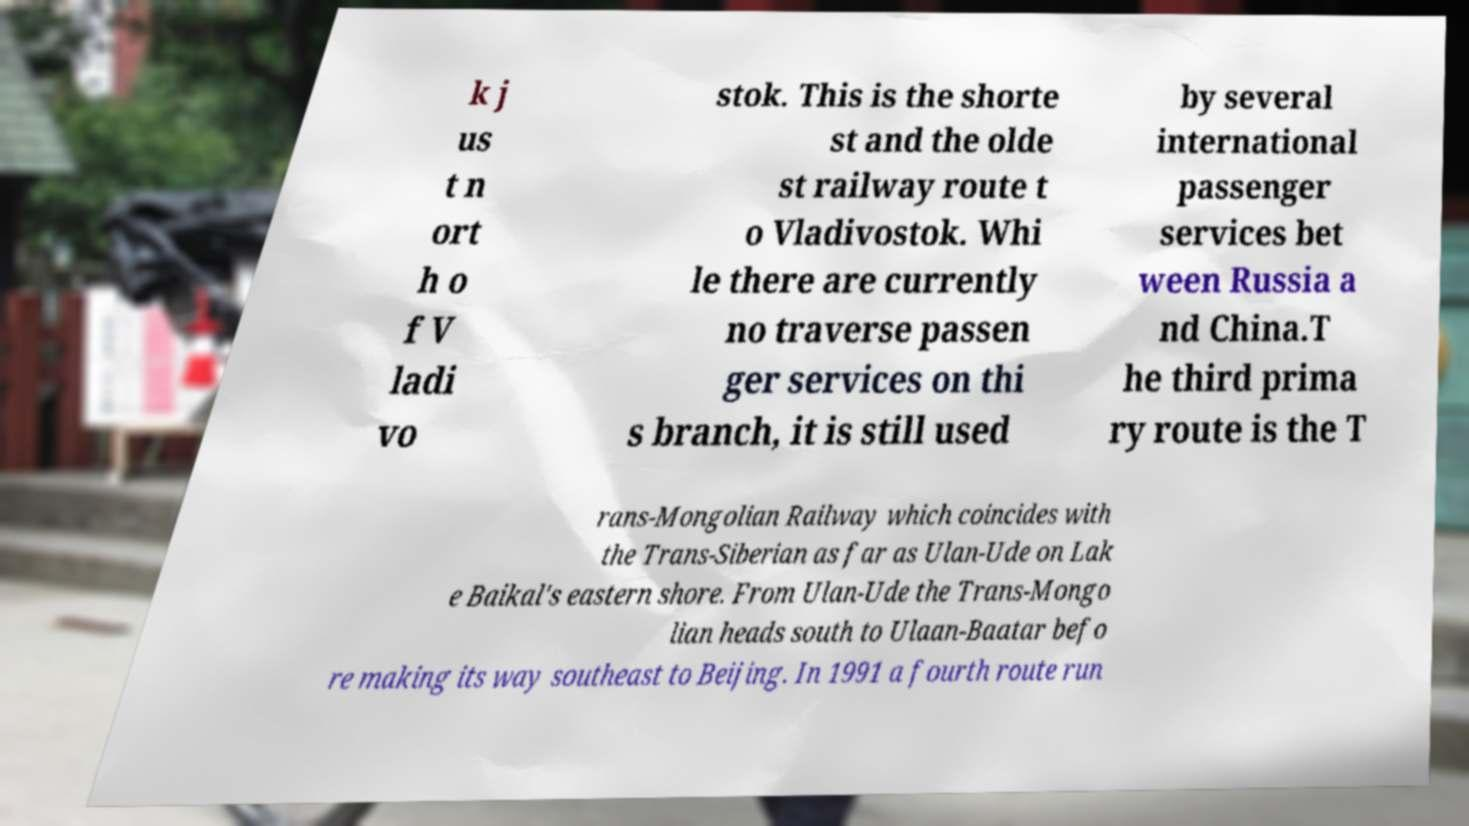Can you read and provide the text displayed in the image?This photo seems to have some interesting text. Can you extract and type it out for me? k j us t n ort h o f V ladi vo stok. This is the shorte st and the olde st railway route t o Vladivostok. Whi le there are currently no traverse passen ger services on thi s branch, it is still used by several international passenger services bet ween Russia a nd China.T he third prima ry route is the T rans-Mongolian Railway which coincides with the Trans-Siberian as far as Ulan-Ude on Lak e Baikal's eastern shore. From Ulan-Ude the Trans-Mongo lian heads south to Ulaan-Baatar befo re making its way southeast to Beijing. In 1991 a fourth route run 